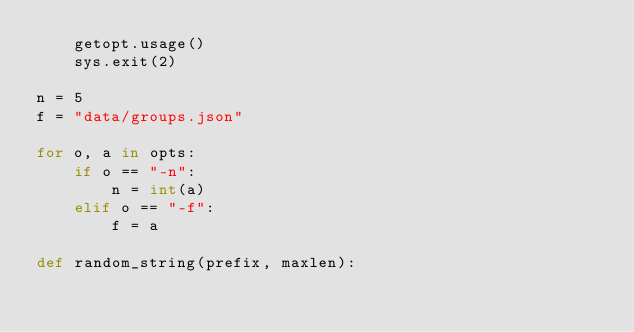<code> <loc_0><loc_0><loc_500><loc_500><_Python_>    getopt.usage()
    sys.exit(2)

n = 5
f = "data/groups.json"

for o, a in opts:
    if o == "-n":
        n = int(a)
    elif o == "-f":
        f = a

def random_string(prefix, maxlen):</code> 